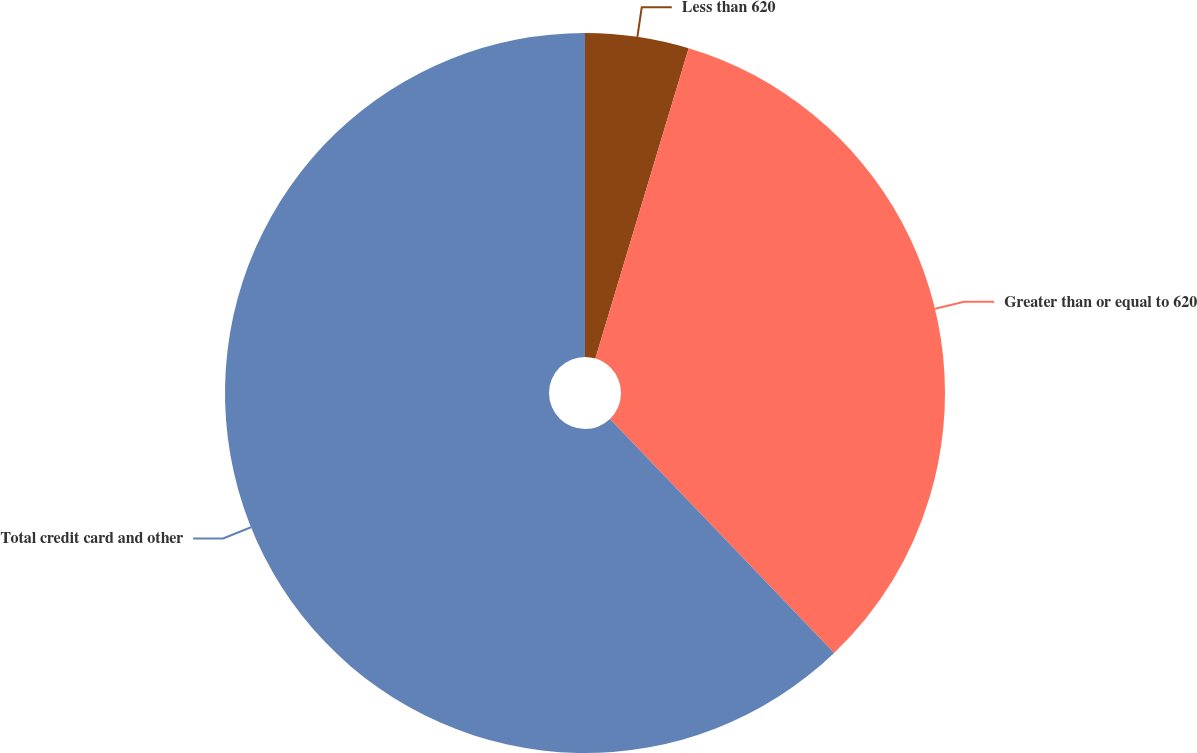Convert chart to OTSL. <chart><loc_0><loc_0><loc_500><loc_500><pie_chart><fcel>Less than 620<fcel>Greater than or equal to 620<fcel>Total credit card and other<nl><fcel>4.65%<fcel>33.19%<fcel>62.17%<nl></chart> 